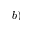<formula> <loc_0><loc_0><loc_500><loc_500>b )</formula> 